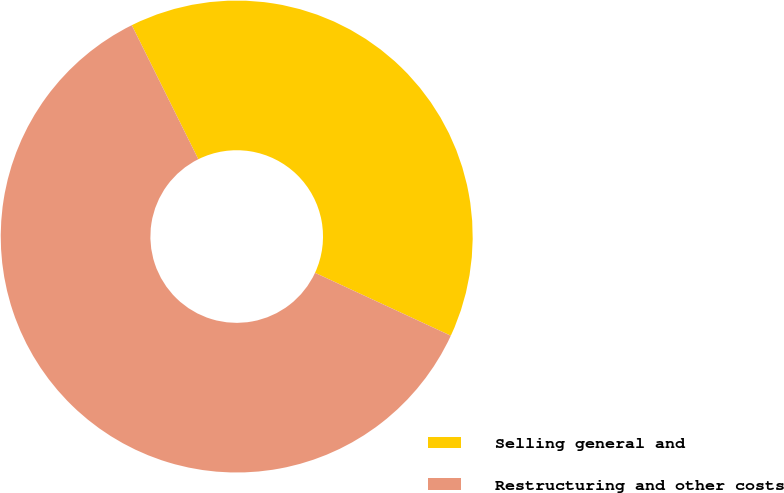<chart> <loc_0><loc_0><loc_500><loc_500><pie_chart><fcel>Selling general and<fcel>Restructuring and other costs<nl><fcel>39.24%<fcel>60.76%<nl></chart> 